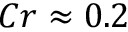<formula> <loc_0><loc_0><loc_500><loc_500>C r \approx 0 . 2</formula> 